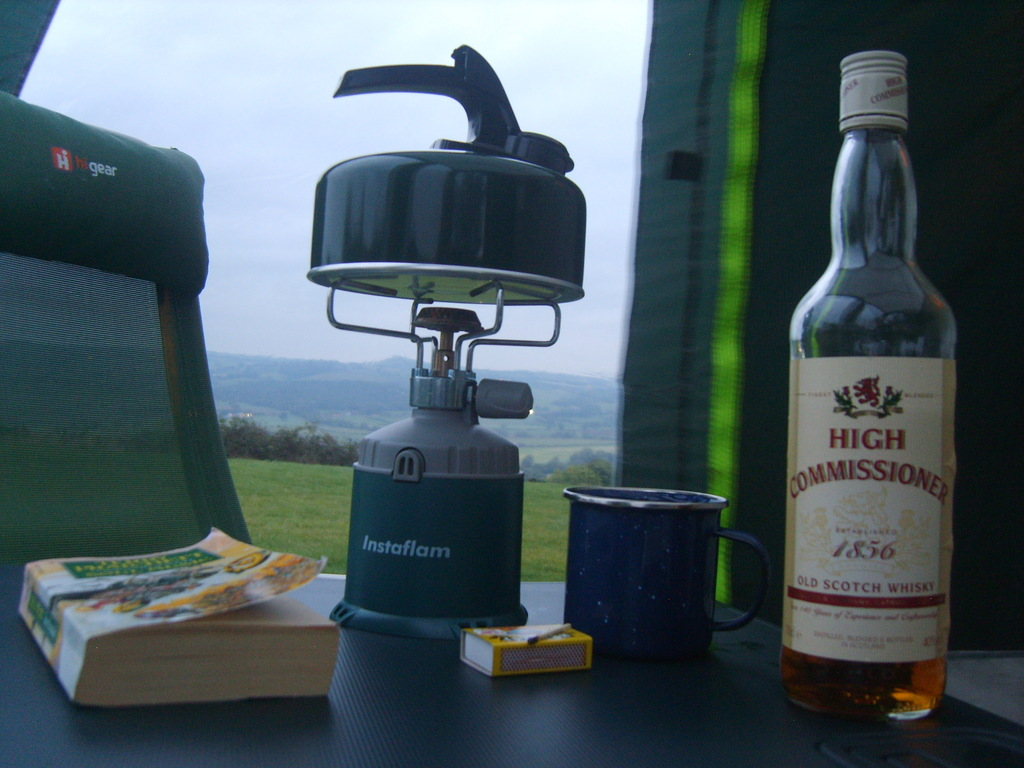Can you describe the setting beyond the items on the table? The setting includes lush green fields stretching into the distance under a faintly lit sky, indicating an early morning or late evening. This tranquil, wide-open space is ideal for camping, provides a sense of peace and solitude. 